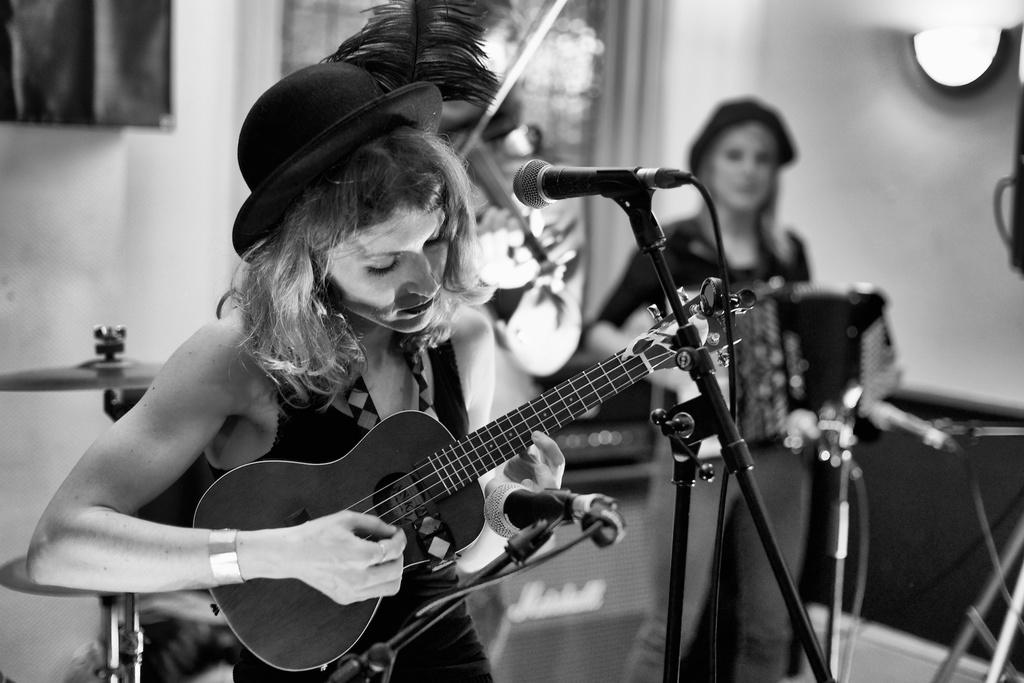How many people are present in the image? There are two people in the image. Can you describe one of the people in the image? One of the people is a woman. What is the woman doing in the image? The woman is playing a guitar. What can be seen in the background of the image? There is a wall in the background of the image. What type of vest is the woman wearing in the image? There is no vest visible in the image; the woman is wearing a dress while playing the guitar. 